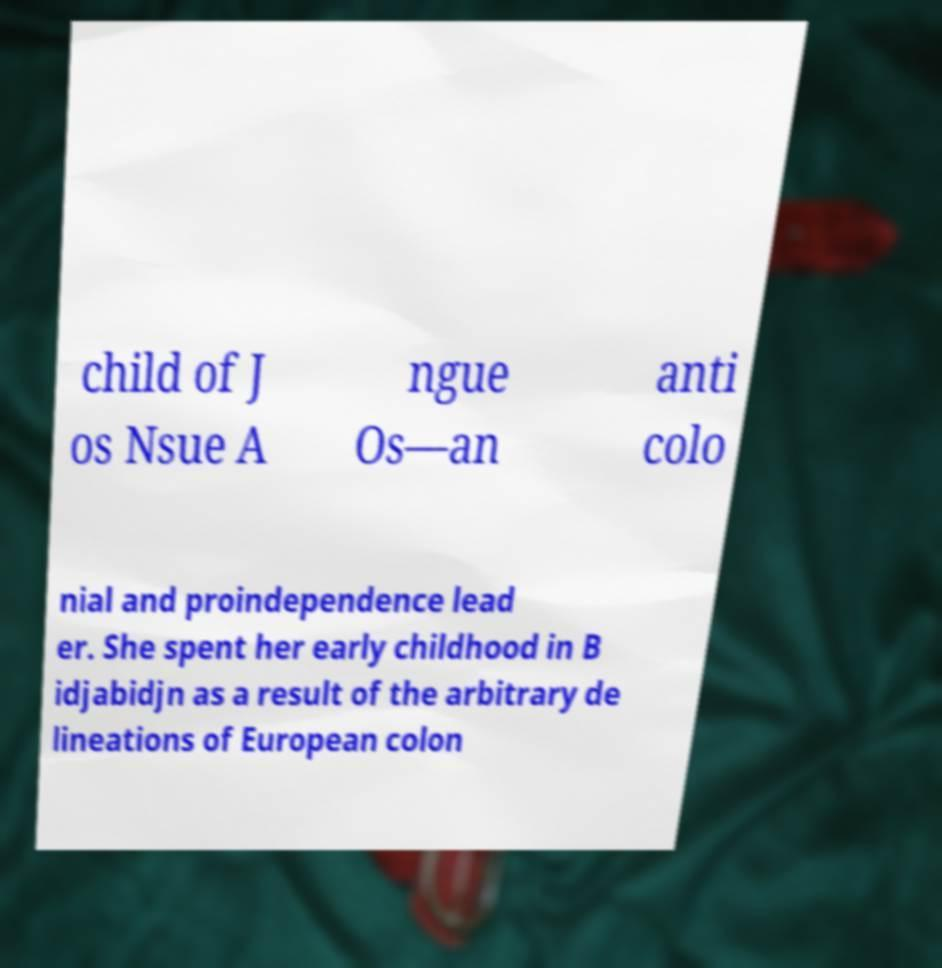For documentation purposes, I need the text within this image transcribed. Could you provide that? child of J os Nsue A ngue Os—an anti colo nial and proindependence lead er. She spent her early childhood in B idjabidjn as a result of the arbitrary de lineations of European colon 